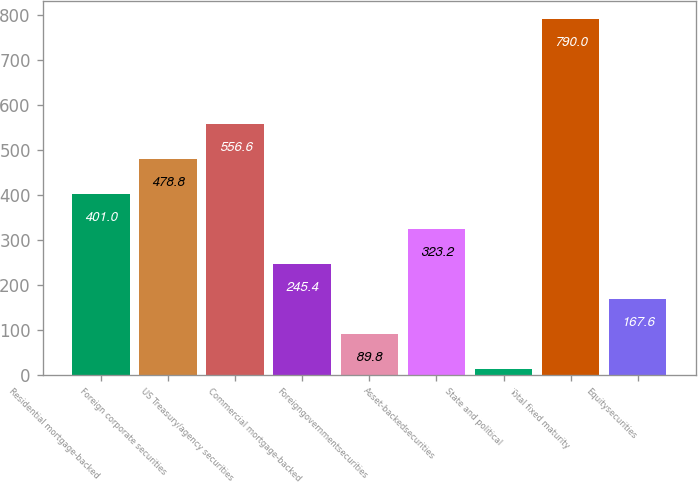<chart> <loc_0><loc_0><loc_500><loc_500><bar_chart><fcel>Residential mortgage-backed<fcel>Foreign corporate securities<fcel>US Treasury/agency securities<fcel>Commercial mortgage-backed<fcel>Foreigngovernmentsecurities<fcel>Asset-backedsecurities<fcel>State and political<fcel>Total fixed maturity<fcel>Equitysecurities<nl><fcel>401<fcel>478.8<fcel>556.6<fcel>245.4<fcel>89.8<fcel>323.2<fcel>12<fcel>790<fcel>167.6<nl></chart> 